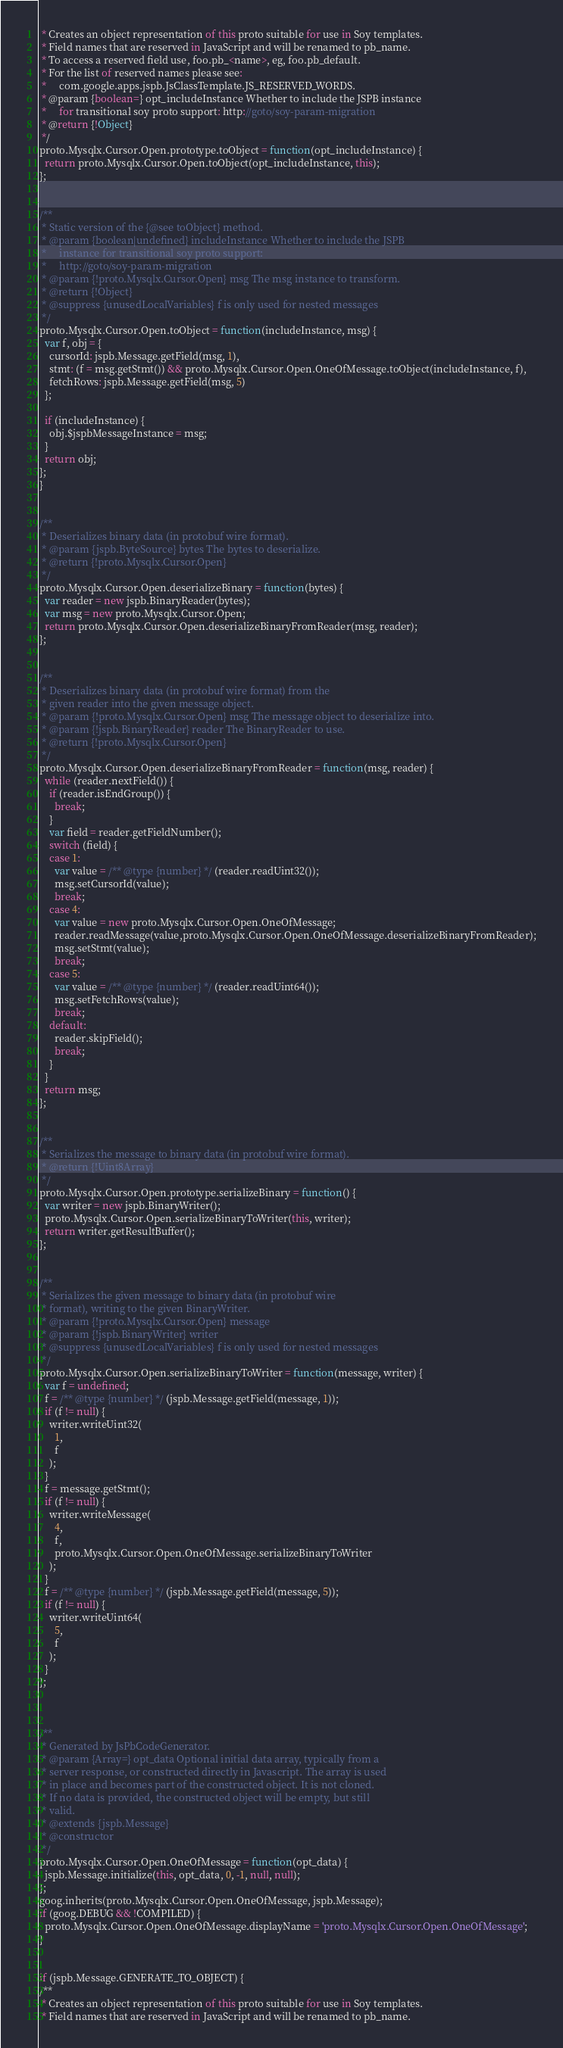<code> <loc_0><loc_0><loc_500><loc_500><_JavaScript_> * Creates an object representation of this proto suitable for use in Soy templates.
 * Field names that are reserved in JavaScript and will be renamed to pb_name.
 * To access a reserved field use, foo.pb_<name>, eg, foo.pb_default.
 * For the list of reserved names please see:
 *     com.google.apps.jspb.JsClassTemplate.JS_RESERVED_WORDS.
 * @param {boolean=} opt_includeInstance Whether to include the JSPB instance
 *     for transitional soy proto support: http://goto/soy-param-migration
 * @return {!Object}
 */
proto.Mysqlx.Cursor.Open.prototype.toObject = function(opt_includeInstance) {
  return proto.Mysqlx.Cursor.Open.toObject(opt_includeInstance, this);
};


/**
 * Static version of the {@see toObject} method.
 * @param {boolean|undefined} includeInstance Whether to include the JSPB
 *     instance for transitional soy proto support:
 *     http://goto/soy-param-migration
 * @param {!proto.Mysqlx.Cursor.Open} msg The msg instance to transform.
 * @return {!Object}
 * @suppress {unusedLocalVariables} f is only used for nested messages
 */
proto.Mysqlx.Cursor.Open.toObject = function(includeInstance, msg) {
  var f, obj = {
    cursorId: jspb.Message.getField(msg, 1),
    stmt: (f = msg.getStmt()) && proto.Mysqlx.Cursor.Open.OneOfMessage.toObject(includeInstance, f),
    fetchRows: jspb.Message.getField(msg, 5)
  };

  if (includeInstance) {
    obj.$jspbMessageInstance = msg;
  }
  return obj;
};
}


/**
 * Deserializes binary data (in protobuf wire format).
 * @param {jspb.ByteSource} bytes The bytes to deserialize.
 * @return {!proto.Mysqlx.Cursor.Open}
 */
proto.Mysqlx.Cursor.Open.deserializeBinary = function(bytes) {
  var reader = new jspb.BinaryReader(bytes);
  var msg = new proto.Mysqlx.Cursor.Open;
  return proto.Mysqlx.Cursor.Open.deserializeBinaryFromReader(msg, reader);
};


/**
 * Deserializes binary data (in protobuf wire format) from the
 * given reader into the given message object.
 * @param {!proto.Mysqlx.Cursor.Open} msg The message object to deserialize into.
 * @param {!jspb.BinaryReader} reader The BinaryReader to use.
 * @return {!proto.Mysqlx.Cursor.Open}
 */
proto.Mysqlx.Cursor.Open.deserializeBinaryFromReader = function(msg, reader) {
  while (reader.nextField()) {
    if (reader.isEndGroup()) {
      break;
    }
    var field = reader.getFieldNumber();
    switch (field) {
    case 1:
      var value = /** @type {number} */ (reader.readUint32());
      msg.setCursorId(value);
      break;
    case 4:
      var value = new proto.Mysqlx.Cursor.Open.OneOfMessage;
      reader.readMessage(value,proto.Mysqlx.Cursor.Open.OneOfMessage.deserializeBinaryFromReader);
      msg.setStmt(value);
      break;
    case 5:
      var value = /** @type {number} */ (reader.readUint64());
      msg.setFetchRows(value);
      break;
    default:
      reader.skipField();
      break;
    }
  }
  return msg;
};


/**
 * Serializes the message to binary data (in protobuf wire format).
 * @return {!Uint8Array}
 */
proto.Mysqlx.Cursor.Open.prototype.serializeBinary = function() {
  var writer = new jspb.BinaryWriter();
  proto.Mysqlx.Cursor.Open.serializeBinaryToWriter(this, writer);
  return writer.getResultBuffer();
};


/**
 * Serializes the given message to binary data (in protobuf wire
 * format), writing to the given BinaryWriter.
 * @param {!proto.Mysqlx.Cursor.Open} message
 * @param {!jspb.BinaryWriter} writer
 * @suppress {unusedLocalVariables} f is only used for nested messages
 */
proto.Mysqlx.Cursor.Open.serializeBinaryToWriter = function(message, writer) {
  var f = undefined;
  f = /** @type {number} */ (jspb.Message.getField(message, 1));
  if (f != null) {
    writer.writeUint32(
      1,
      f
    );
  }
  f = message.getStmt();
  if (f != null) {
    writer.writeMessage(
      4,
      f,
      proto.Mysqlx.Cursor.Open.OneOfMessage.serializeBinaryToWriter
    );
  }
  f = /** @type {number} */ (jspb.Message.getField(message, 5));
  if (f != null) {
    writer.writeUint64(
      5,
      f
    );
  }
};



/**
 * Generated by JsPbCodeGenerator.
 * @param {Array=} opt_data Optional initial data array, typically from a
 * server response, or constructed directly in Javascript. The array is used
 * in place and becomes part of the constructed object. It is not cloned.
 * If no data is provided, the constructed object will be empty, but still
 * valid.
 * @extends {jspb.Message}
 * @constructor
 */
proto.Mysqlx.Cursor.Open.OneOfMessage = function(opt_data) {
  jspb.Message.initialize(this, opt_data, 0, -1, null, null);
};
goog.inherits(proto.Mysqlx.Cursor.Open.OneOfMessage, jspb.Message);
if (goog.DEBUG && !COMPILED) {
  proto.Mysqlx.Cursor.Open.OneOfMessage.displayName = 'proto.Mysqlx.Cursor.Open.OneOfMessage';
}


if (jspb.Message.GENERATE_TO_OBJECT) {
/**
 * Creates an object representation of this proto suitable for use in Soy templates.
 * Field names that are reserved in JavaScript and will be renamed to pb_name.</code> 